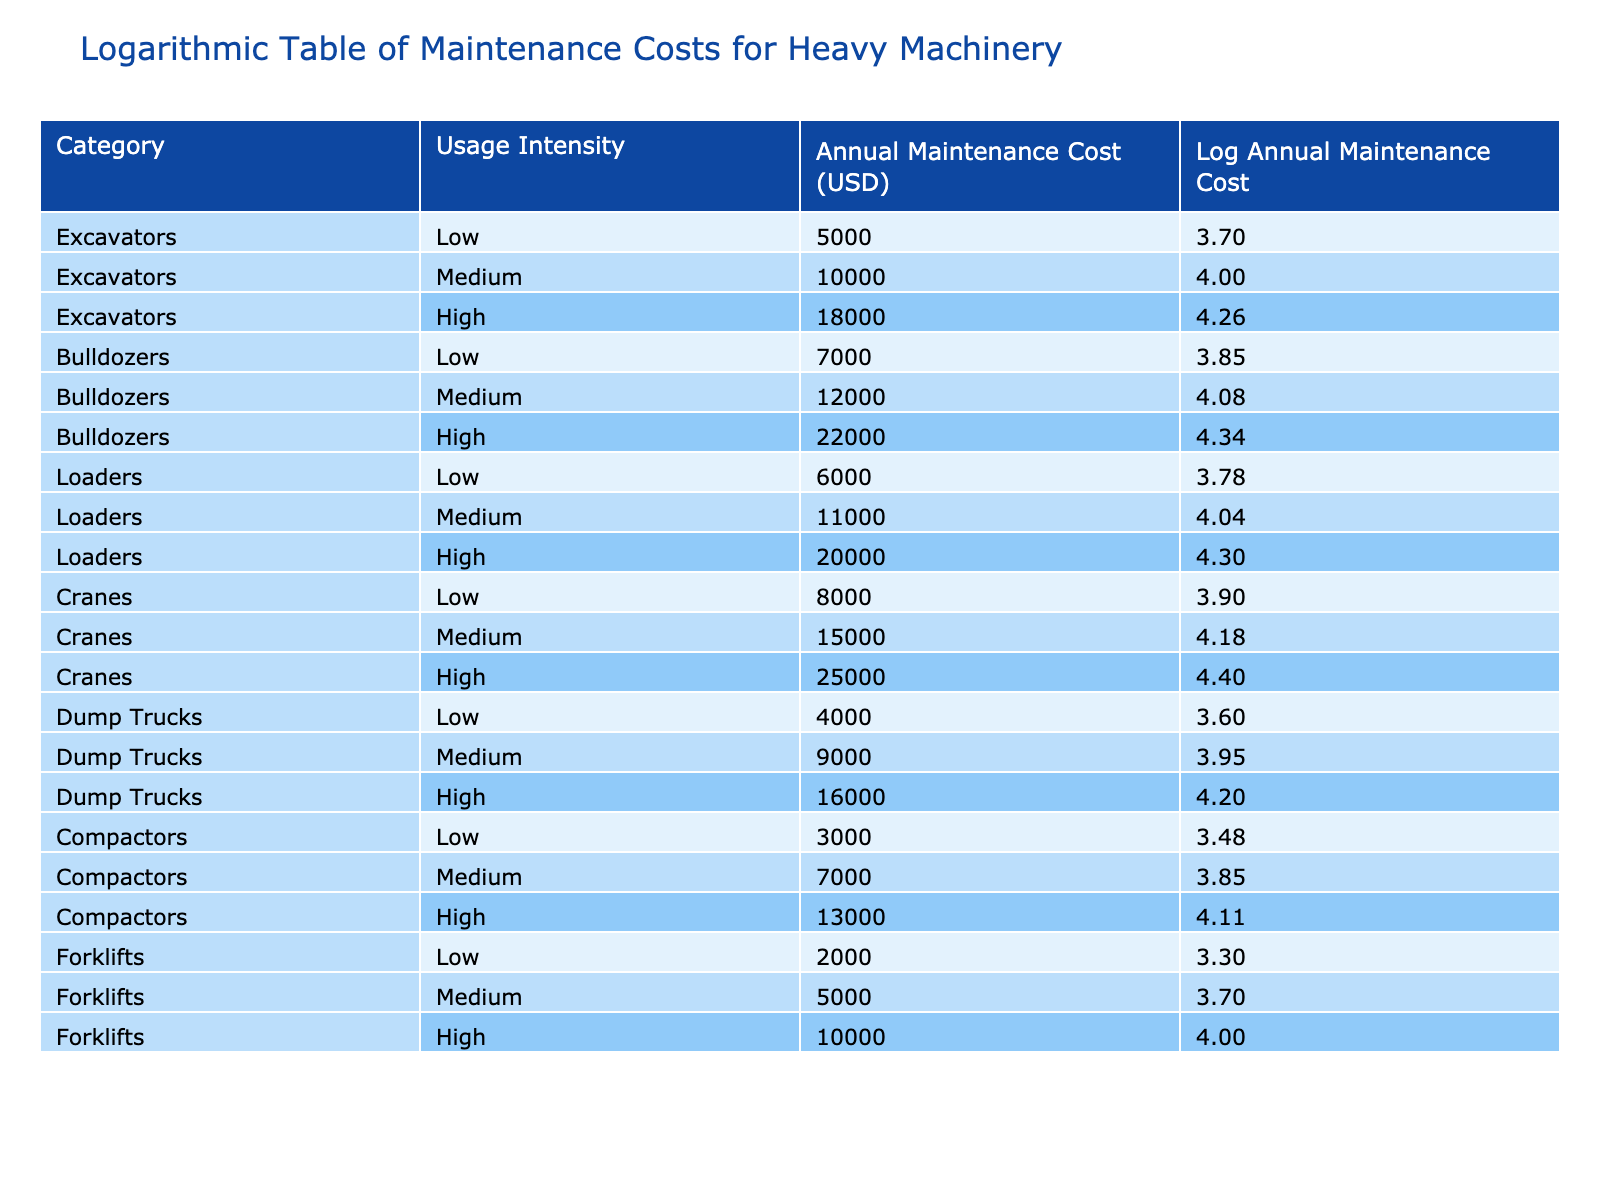What is the annual maintenance cost for high intensity excavators? The table shows that the annual maintenance cost for excavators under high usage intensity is listed as 18000 USD.
Answer: 18000 USD Which machinery category has the highest annual maintenance cost for low usage intensity? By examining the table, we see that cranes have the highest maintenance cost for low usage intensity at 8000 USD compared to excavators (5000 USD), bulldozers (7000 USD), loaders (6000 USD), dump trucks (4000 USD), compactors (3000 USD), and forklifts (2000 USD).
Answer: Cranes Is the maintenance cost for medium usage intensity loaders less than 12000 USD? The table indicates that the maintenance cost for loaders at medium intensity is 11000 USD, which is indeed less than 12000 USD.
Answer: Yes What is the total annual maintenance cost for all bulldozer categories? The maintenance costs for bulldozers are 7000 USD for low, 12000 USD for medium, and 22000 USD for high usage intensity. Adding these gives 7000 + 12000 + 22000 = 41000 USD.
Answer: 41000 USD Which has a greater annual maintenance cost, high intensity dump trucks or medium intensity compactors? Looking at the table, dump trucks under high intensity have a cost of 16000 USD, while compactors under medium intensity cost 7000 USD. Since 16000 is greater than 7000, we conclude high intensity dump trucks have a higher cost.
Answer: High intensity dump trucks What is the average annual maintenance cost across all types of forklifts? The costs for forklifts are 2000 USD for low, 5000 USD for medium, and 10000 USD for high usage intensity. The total is 2000 + 5000 + 10000 = 17000 USD, and there are 3 types of forklifts, so the average is 17000 / 3 = approximately 5666.67 USD.
Answer: Approximately 5666.67 USD Does medium intensity usage of excavators have a higher maintenance cost than low intensity usage of bulldozers? Medium intensity excavators have a cost of 10000 USD, while low intensity bulldozers cost 7000 USD. Since 10000 is greater than 7000, we know that medium excavators have a higher cost.
Answer: Yes What is the difference in annual maintenance costs between high intensity cranes and low intensity forklifts? The high intensity cost for cranes is 25000 USD, and the low intensity cost for forklifts is 2000 USD. The difference is calculated as 25000 - 2000 = 23000 USD.
Answer: 23000 USD 